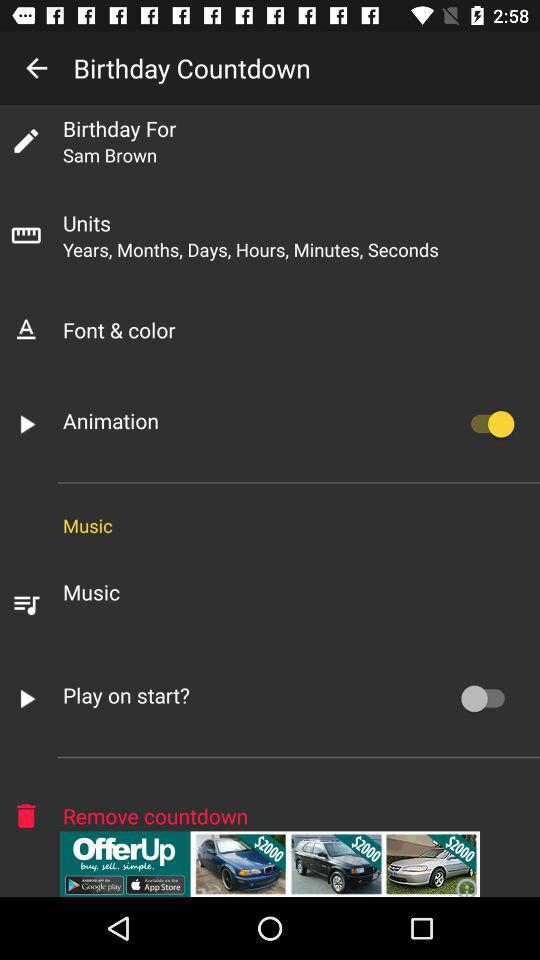What is the name of the person? The name is Sam Brown. 